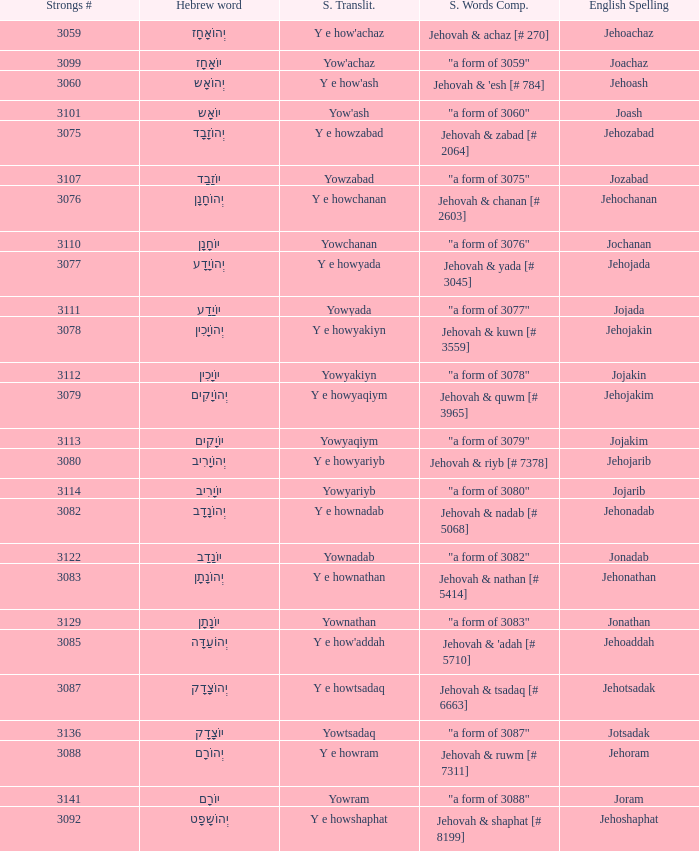What is the strongs transliteration of the hebrew word יוֹחָנָן? Yowchanan. 